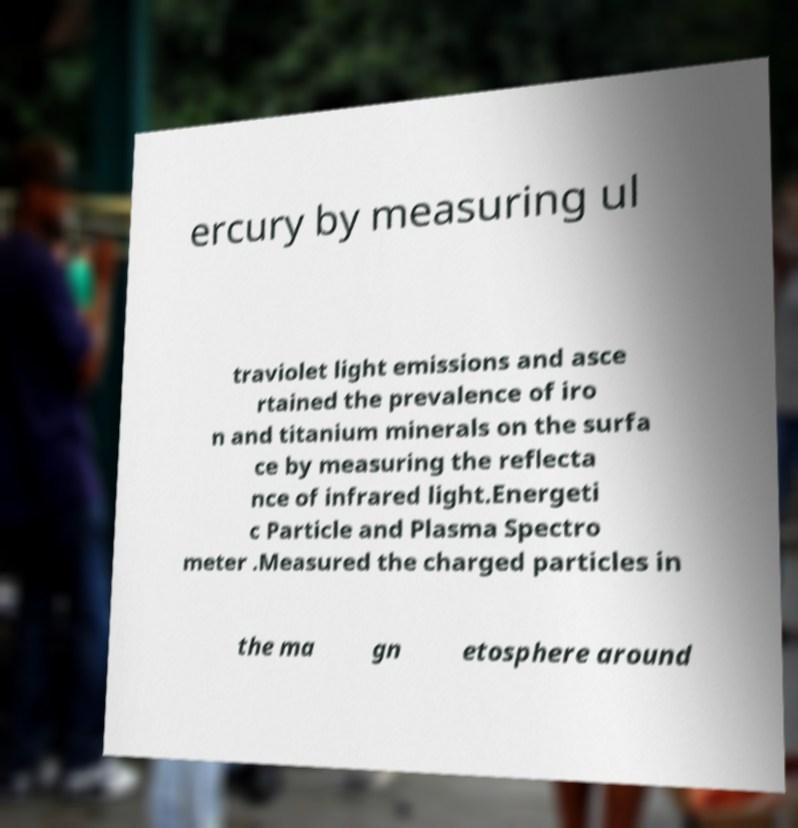Can you accurately transcribe the text from the provided image for me? ercury by measuring ul traviolet light emissions and asce rtained the prevalence of iro n and titanium minerals on the surfa ce by measuring the reflecta nce of infrared light.Energeti c Particle and Plasma Spectro meter .Measured the charged particles in the ma gn etosphere around 